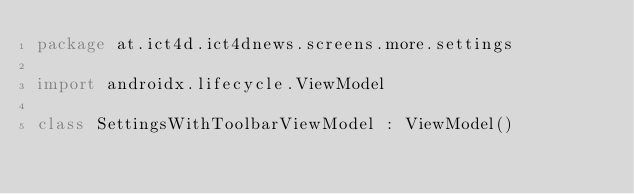<code> <loc_0><loc_0><loc_500><loc_500><_Kotlin_>package at.ict4d.ict4dnews.screens.more.settings

import androidx.lifecycle.ViewModel

class SettingsWithToolbarViewModel : ViewModel()
</code> 